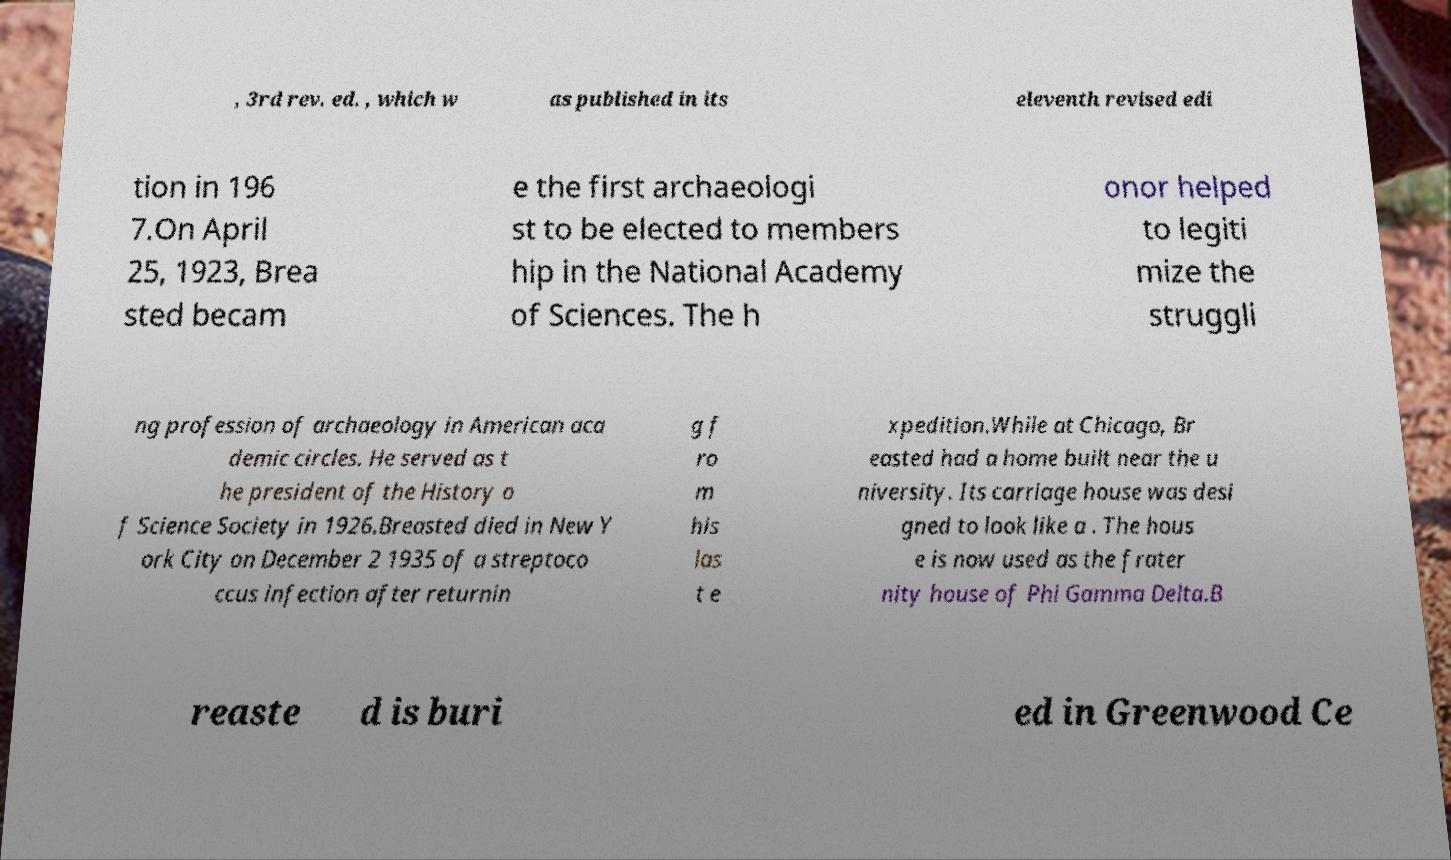There's text embedded in this image that I need extracted. Can you transcribe it verbatim? , 3rd rev. ed. , which w as published in its eleventh revised edi tion in 196 7.On April 25, 1923, Brea sted becam e the first archaeologi st to be elected to members hip in the National Academy of Sciences. The h onor helped to legiti mize the struggli ng profession of archaeology in American aca demic circles. He served as t he president of the History o f Science Society in 1926.Breasted died in New Y ork City on December 2 1935 of a streptoco ccus infection after returnin g f ro m his las t e xpedition.While at Chicago, Br easted had a home built near the u niversity. Its carriage house was desi gned to look like a . The hous e is now used as the frater nity house of Phi Gamma Delta.B reaste d is buri ed in Greenwood Ce 